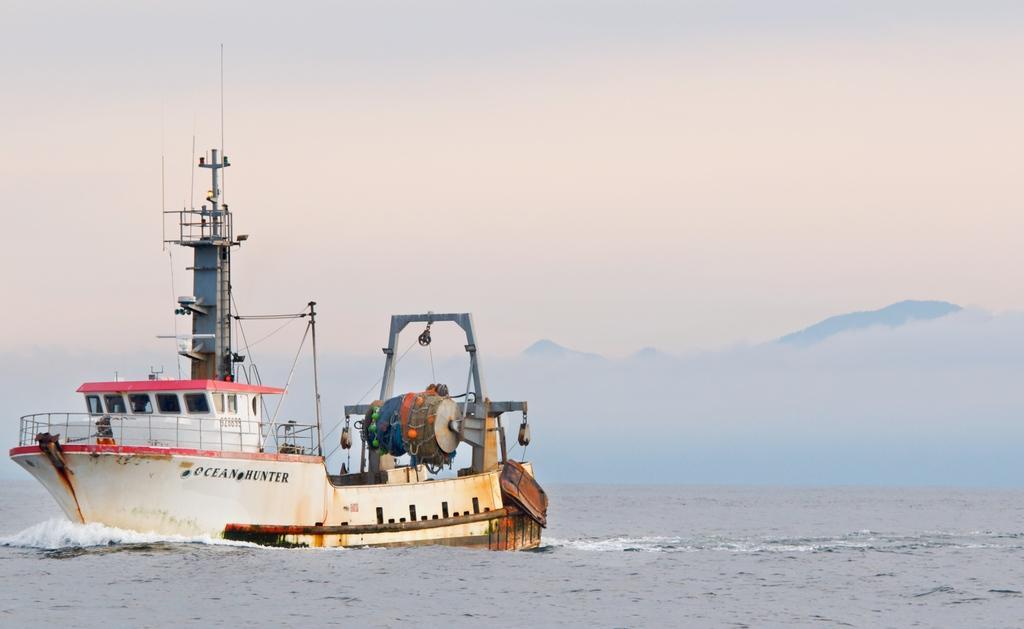Can you describe this image briefly? In this image we can see a ship in a water body. On the backside we can see the hills and the sky which looks cloudy. 